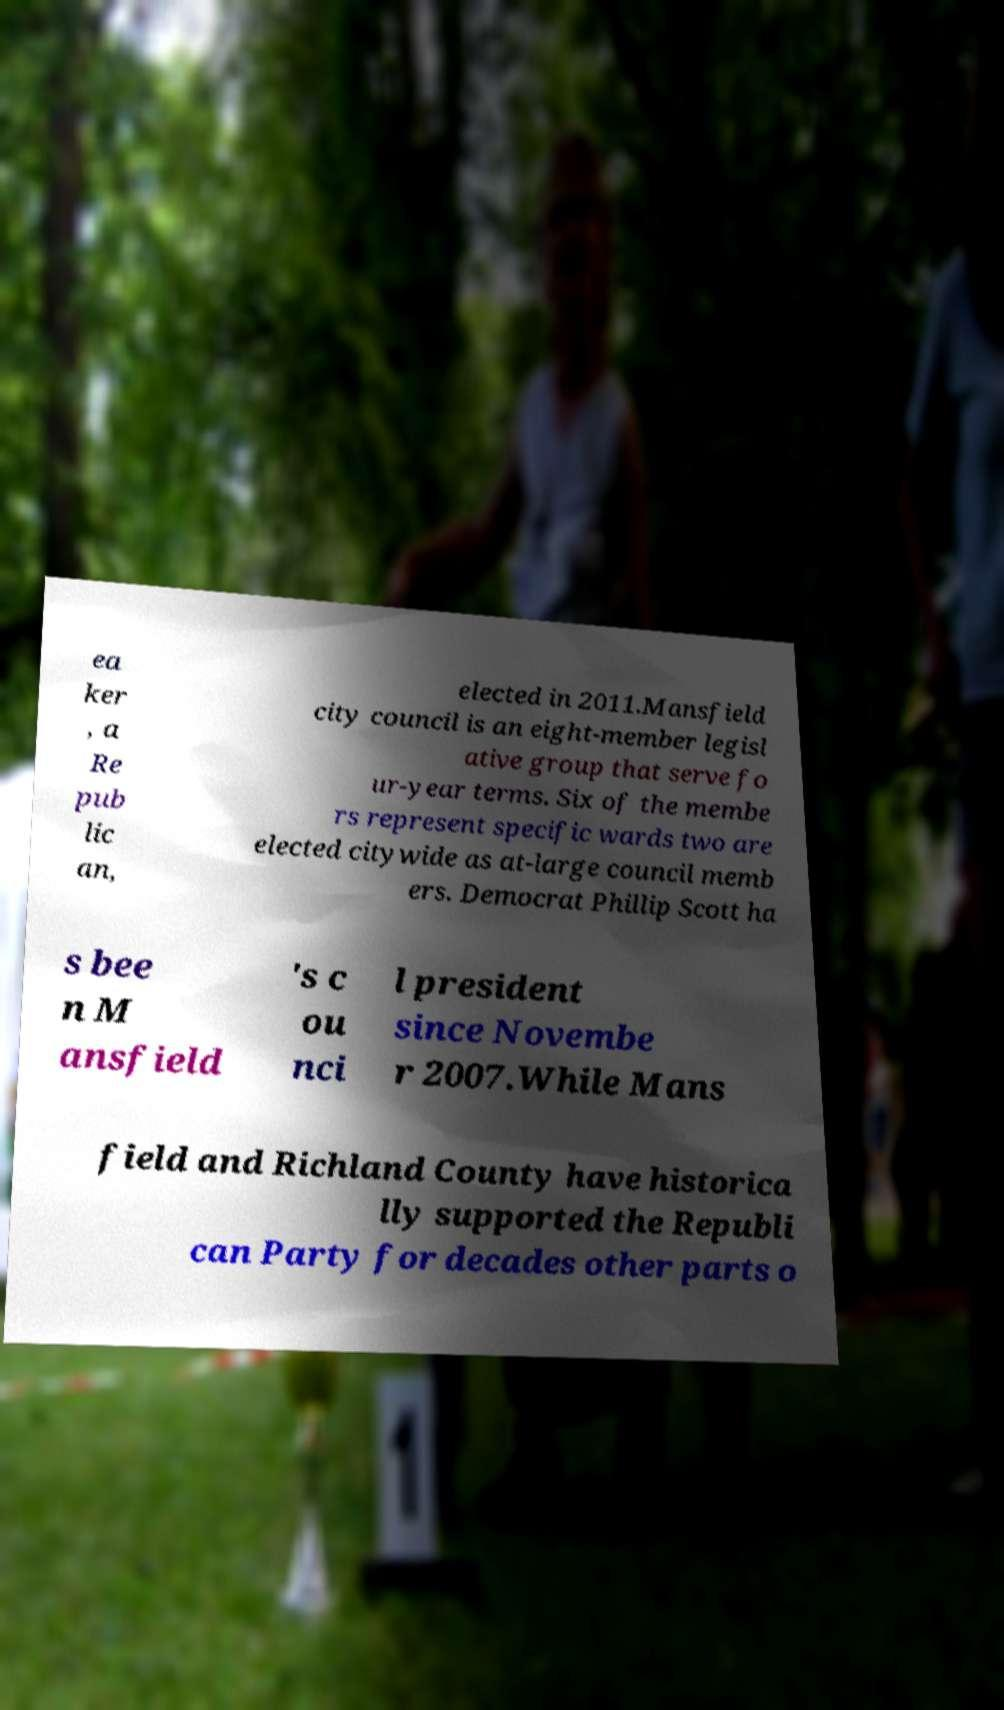Could you extract and type out the text from this image? ea ker , a Re pub lic an, elected in 2011.Mansfield city council is an eight-member legisl ative group that serve fo ur-year terms. Six of the membe rs represent specific wards two are elected citywide as at-large council memb ers. Democrat Phillip Scott ha s bee n M ansfield 's c ou nci l president since Novembe r 2007.While Mans field and Richland County have historica lly supported the Republi can Party for decades other parts o 